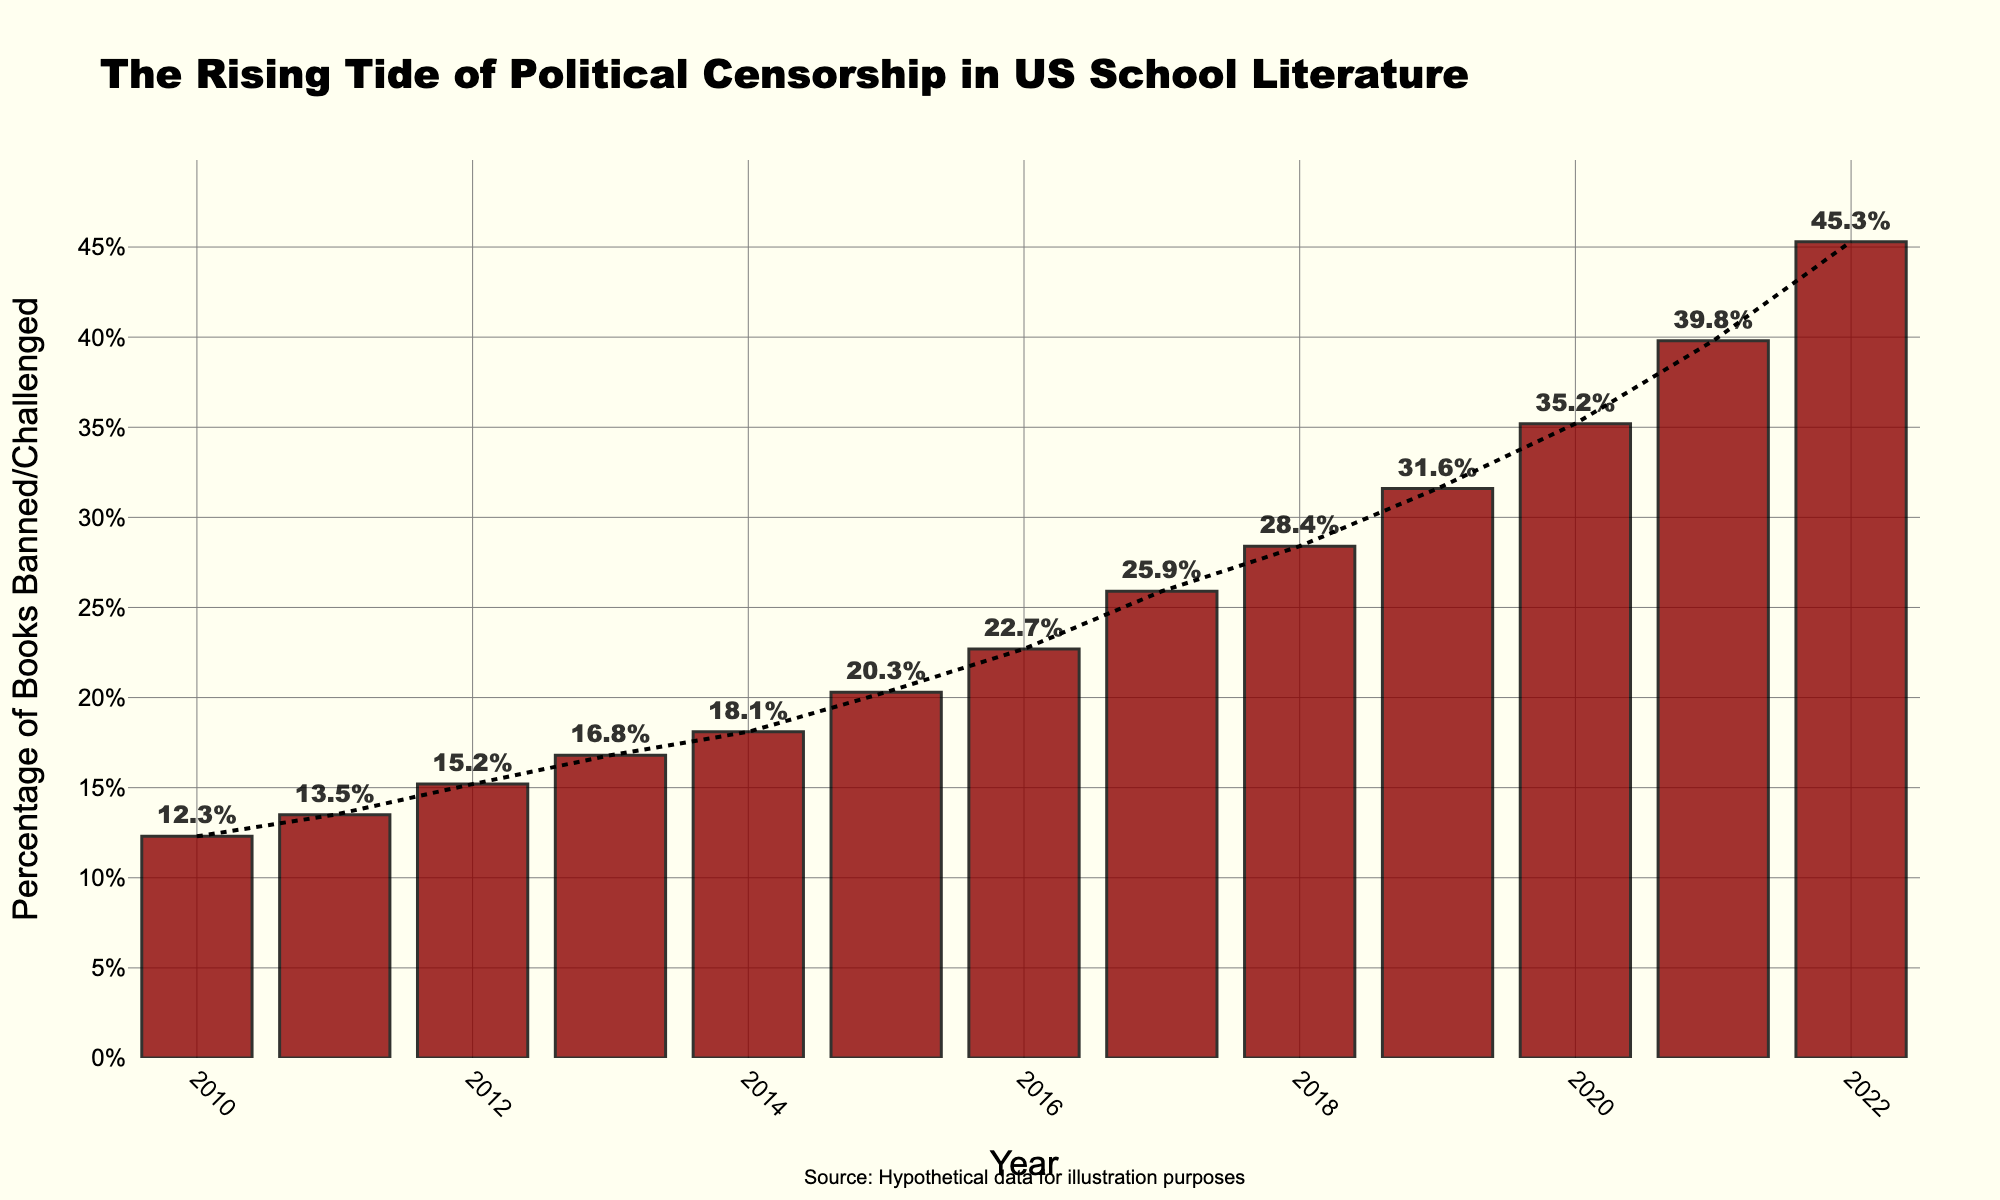What was the percentage of books banned or challenged in 2020? Locate the bar corresponding to the year 2020 and read its height or value label, which is 35.2%.
Answer: 35.2% What is the trend over the years shown in the chart? Observe the overall direction of the bars and the trend line, which both indicate an increasing trend from 2010 to 2022.
Answer: Increasing Between which consecutive years did the percentage increase the most? Calculate the difference in percentage for each consecutive pair of years, and identify the pair with the maximum difference: 2019 to 2020 (35.2 - 31.6 = 3.6%) and 2021 to 2022 (45.3 - 39.8 = 5.5%). The largest increase is between 2021 and 2022.
Answer: 2021 to 2022 What is the average percentage of books banned or challenged from 2010 to 2015? Calculate the average of the percentages from 2010 to 2015: (12.3 + 13.5 + 15.2 + 16.8 + 18.1 + 20.3) / 6 = 96.2 / 6 = 16.03%.
Answer: 16.03% How much did the percentage increase from 2010 to 2022? Subtract the percentage in 2010 from that in 2022: 45.3% - 12.3% = 33%.
Answer: 33% Between which two years was the percentage exactly 39.8%? Look for the bar labeled with 39.8%, which corresponds to the year 2021.
Answer: 2021 Which year had the lowest percentage of books banned or challenged? Identify the shortest bar in the chart or the one with the smallest label, corresponding to the year 2010.
Answer: 2010 Comparing 2015 and 2018, which year had the higher percentage, and by how much? Determine the heights of the bars for 2015 (20.3%) and 2018 (28.4%). Subtract the smaller from the larger: 28.4% - 20.3% = 8.1%.
Answer: 2018, by 8.1% What is the median percentage value from 2010 to 2022? List the percentages in ascending order, and since there are 13 values, the median is the 7th value: (12.3, 13.5, 15.2, 16.8, 18.1, 20.3, 22.7, 25.9, 28.4, 31.6, 35.2, 39.8, 45.3). The median is 22.7%.
Answer: 22.7% Identify the visual impact of the trend line added to the chart. The trend line visually emphasizes the increasing trend of the bars over time, indicating a general rise in the percentage of books banned or challenged.
Answer: Highlights increasing trend 